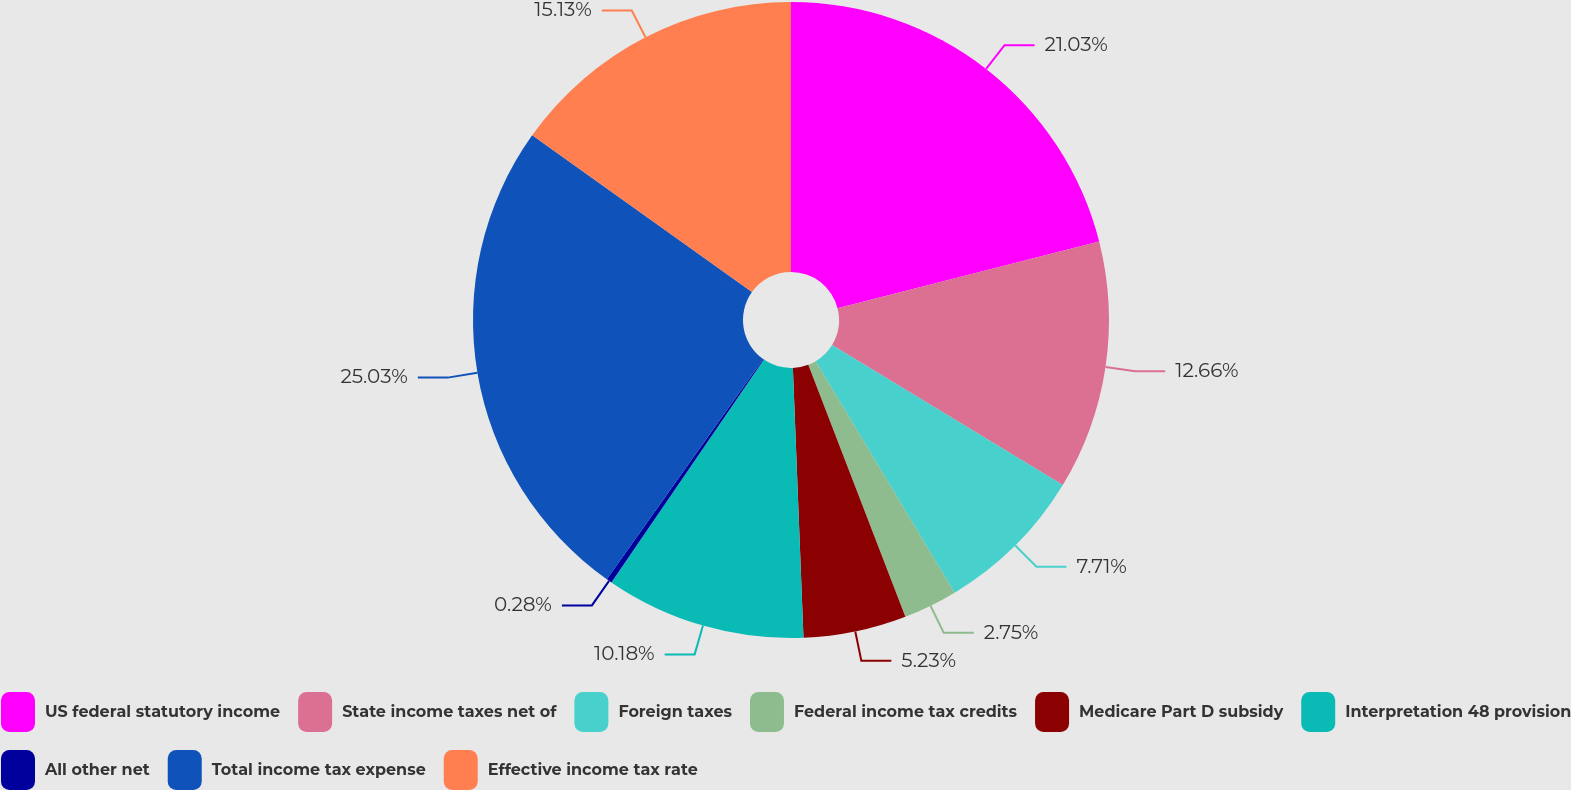Convert chart to OTSL. <chart><loc_0><loc_0><loc_500><loc_500><pie_chart><fcel>US federal statutory income<fcel>State income taxes net of<fcel>Foreign taxes<fcel>Federal income tax credits<fcel>Medicare Part D subsidy<fcel>Interpretation 48 provision<fcel>All other net<fcel>Total income tax expense<fcel>Effective income tax rate<nl><fcel>21.03%<fcel>12.66%<fcel>7.71%<fcel>2.75%<fcel>5.23%<fcel>10.18%<fcel>0.28%<fcel>25.04%<fcel>15.13%<nl></chart> 